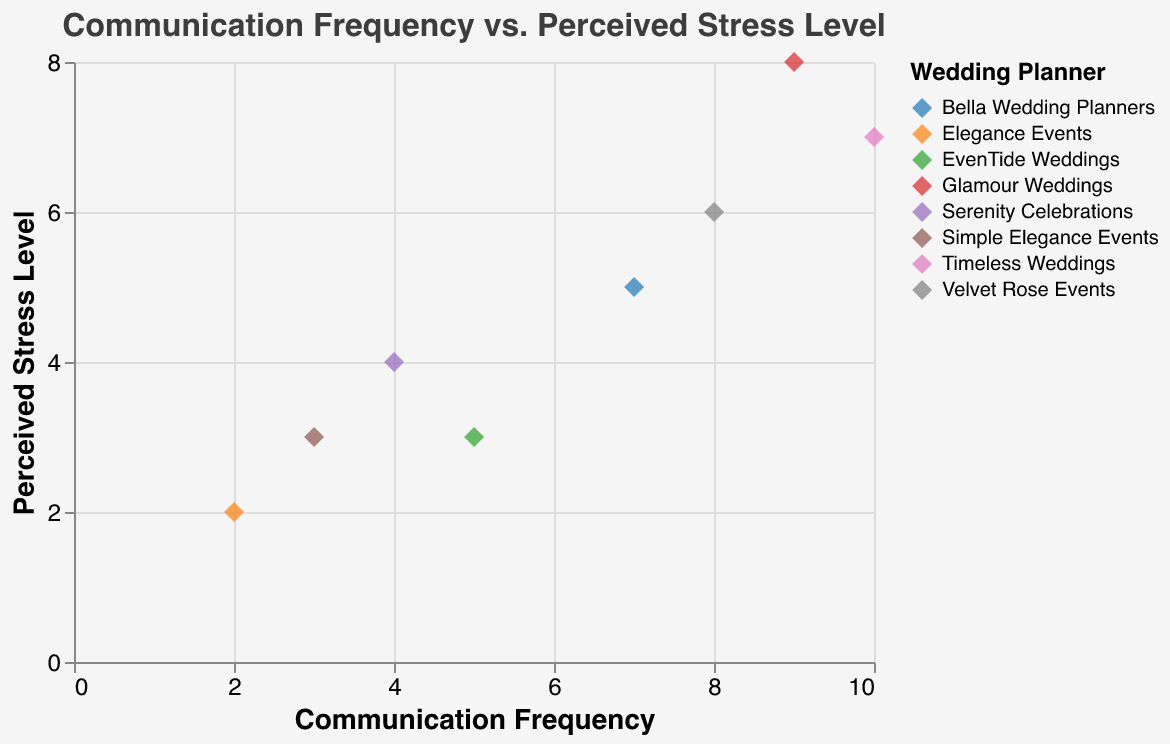What is the title of the scatter plot? The title of a plot is usually found at the top. In this figure, the title is displayed exactly there.
Answer: Communication Frequency vs. Perceived Stress Level How many data points are displayed in the scatter plot? By counting each plotted point in the scatter plot, you can determine the number of data points.
Answer: 8 Which couple has the highest perceived stress level? Look for the data point that reaches the highest value on the y-axis.
Answer: Amy and James Is there a couple with both low communication frequency and low perceived stress level? Look for data points located at the lower values of both the x-axis (communication frequency) and y-axis (perceived stress level).
Answer: Lisa and Tom Which couple interacts most frequently with their wedding planner? Find the data point that is farthest right on the x-axis (communication frequency).
Answer: Angela and Mark What is the perceived stress level for Sarah and John? Identify the data point for Sarah and John and read the y-axis value.
Answer: 3 Compare the communication frequency between Amy and James with Claire and Paul. Which couple has more frequent communication? Locate the data points for Amy and James and Claire and Paul, then compare their x-axis values.
Answer: Amy and James What is the relationship between communication frequency and perceived stress level for the couple Emma and Liam? Identify the data point for Emma and Liam and assess their x and y-axis values to determine their relationship.
Answer: Communication frequency is 8, Perceived stress level is 6 Which wedding planner works with the couple that perceives the lowest stress level? Locate the couple with the minimum y-axis value and identify their wedding planner from the tooltip or color legend.
Answer: Elegance Events Is there a general trend between communication frequency and perceived stress level? Observe the overall pattern of the data points to see if there is an apparent relationship between the axes.
Answer: Higher communication frequency generally corresponds to higher perceived stress levels 